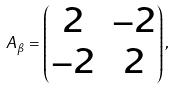<formula> <loc_0><loc_0><loc_500><loc_500>A _ { \beta } = \left ( \begin{matrix} 2 & - 2 \\ - 2 & 2 \\ \end{matrix} \right ) ,</formula> 